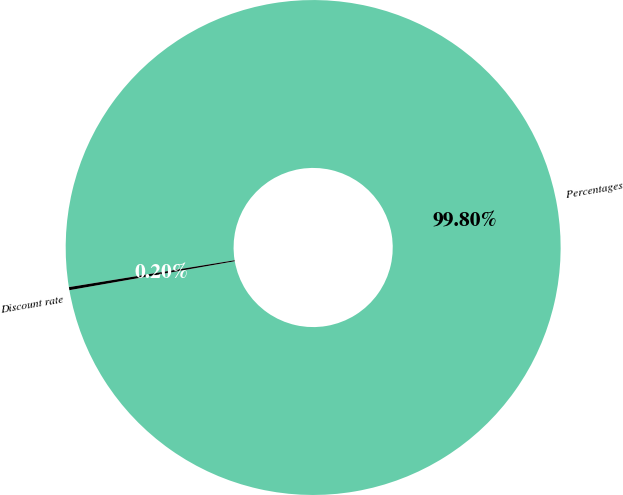Convert chart. <chart><loc_0><loc_0><loc_500><loc_500><pie_chart><fcel>Percentages<fcel>Discount rate<nl><fcel>99.8%<fcel>0.2%<nl></chart> 